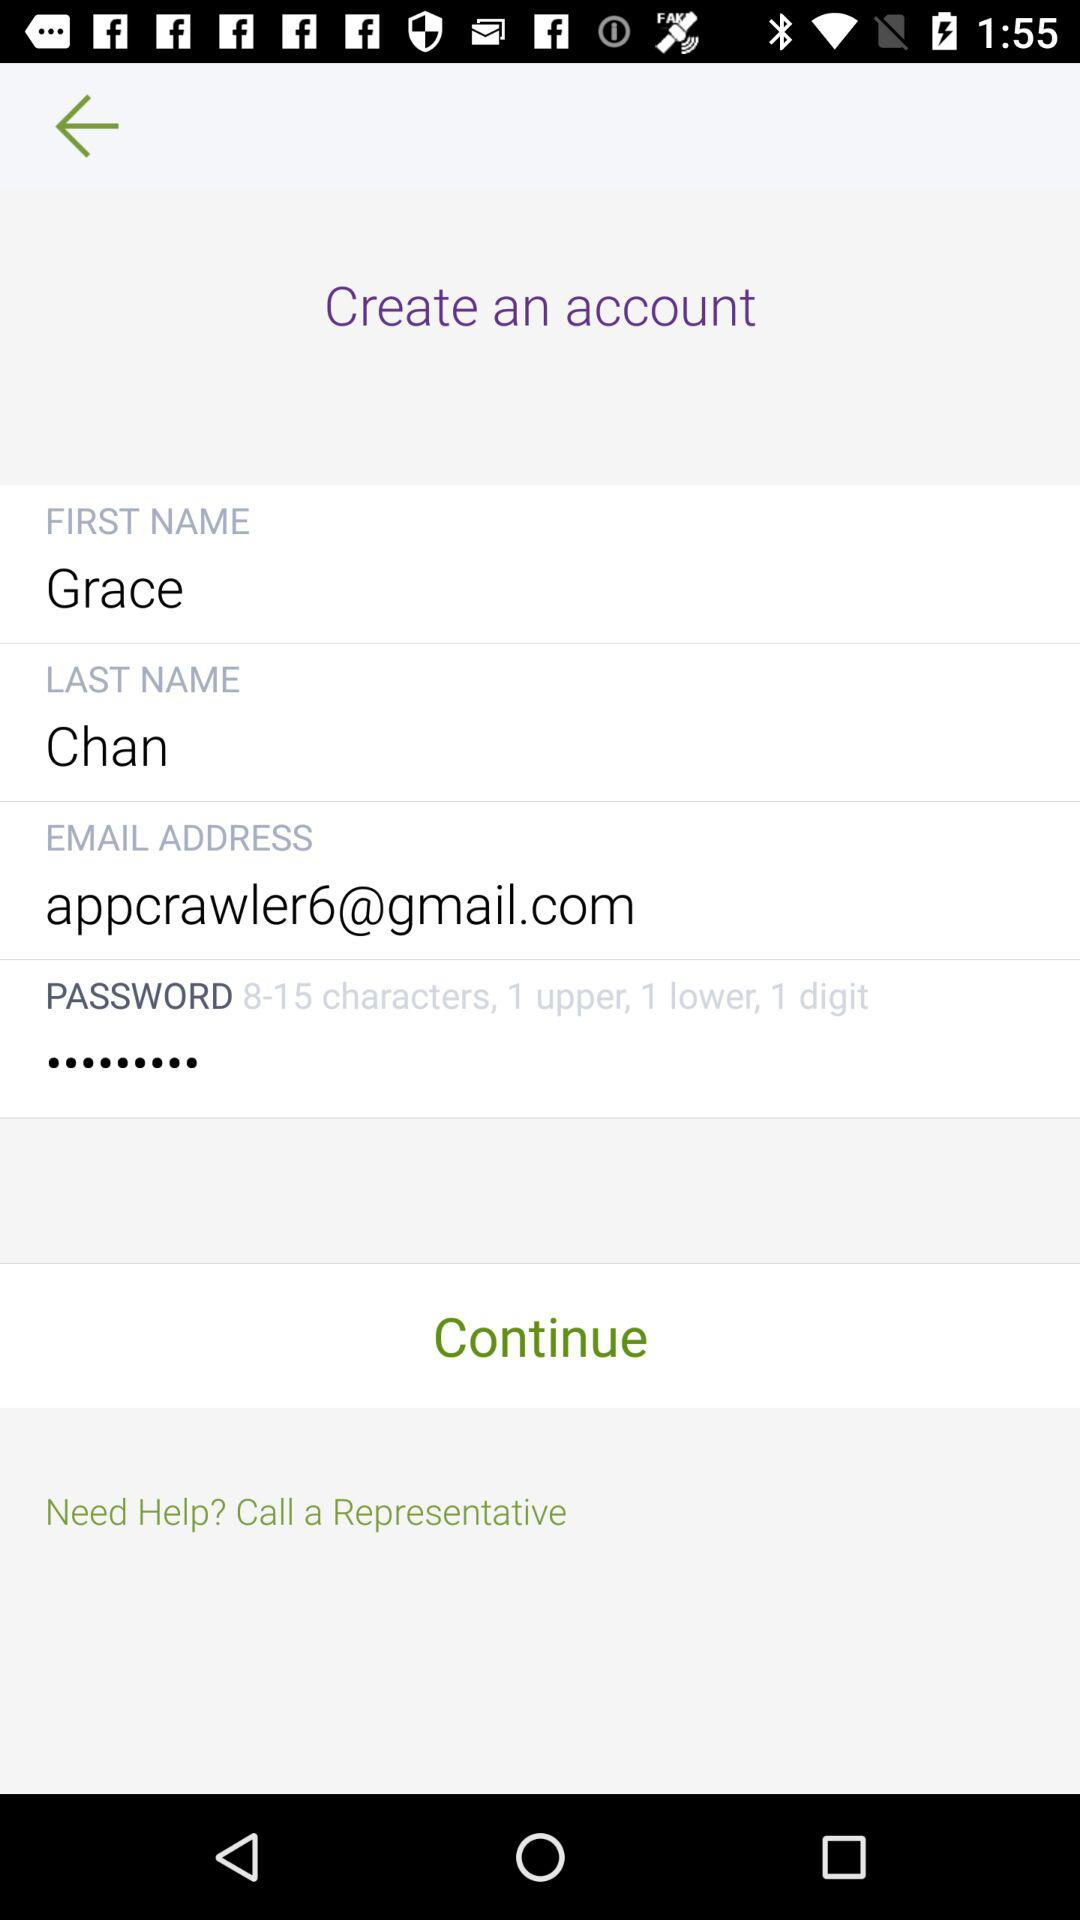What is the first name? The first name is Grace. 